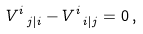Convert formula to latex. <formula><loc_0><loc_0><loc_500><loc_500>V ^ { i } _ { \ j | i } - V ^ { i } _ { \ i | j } = 0 \, ,</formula> 